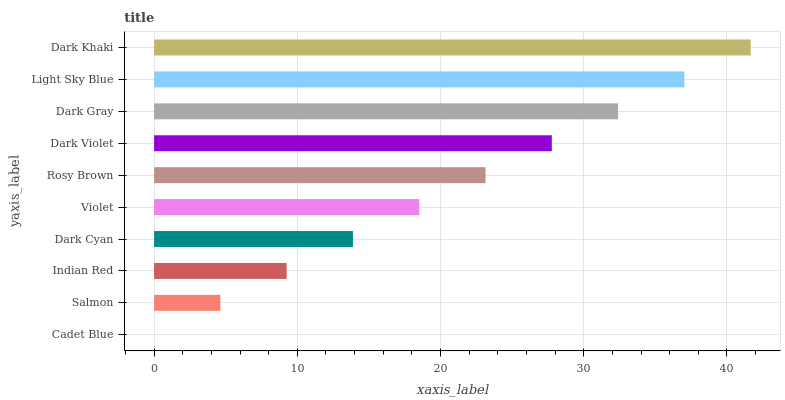Is Cadet Blue the minimum?
Answer yes or no. Yes. Is Dark Khaki the maximum?
Answer yes or no. Yes. Is Salmon the minimum?
Answer yes or no. No. Is Salmon the maximum?
Answer yes or no. No. Is Salmon greater than Cadet Blue?
Answer yes or no. Yes. Is Cadet Blue less than Salmon?
Answer yes or no. Yes. Is Cadet Blue greater than Salmon?
Answer yes or no. No. Is Salmon less than Cadet Blue?
Answer yes or no. No. Is Rosy Brown the high median?
Answer yes or no. Yes. Is Violet the low median?
Answer yes or no. Yes. Is Dark Khaki the high median?
Answer yes or no. No. Is Salmon the low median?
Answer yes or no. No. 